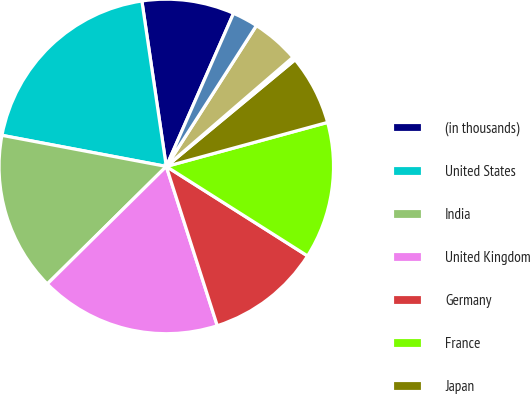<chart> <loc_0><loc_0><loc_500><loc_500><pie_chart><fcel>(in thousands)<fcel>United States<fcel>India<fcel>United Kingdom<fcel>Germany<fcel>France<fcel>Japan<fcel>Canada<fcel>Other European<fcel>Other international<nl><fcel>8.92%<fcel>19.69%<fcel>15.38%<fcel>17.53%<fcel>11.08%<fcel>13.23%<fcel>6.77%<fcel>0.31%<fcel>4.62%<fcel>2.47%<nl></chart> 